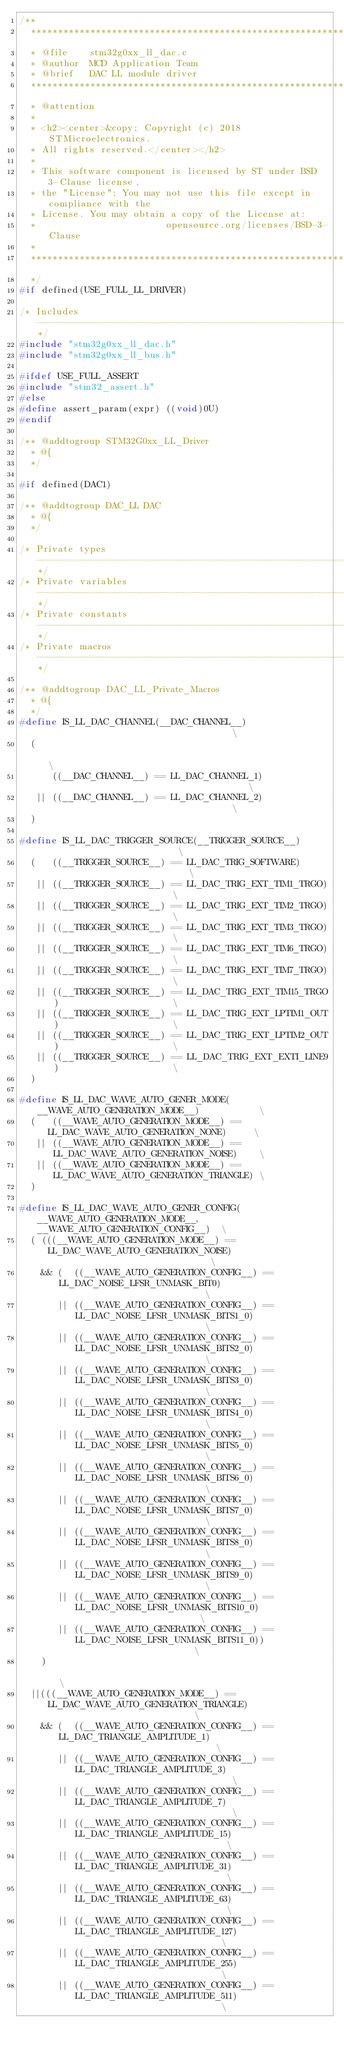<code> <loc_0><loc_0><loc_500><loc_500><_C_>/**
  ******************************************************************************
  * @file    stm32g0xx_ll_dac.c
  * @author  MCD Application Team
  * @brief   DAC LL module driver
  ******************************************************************************
  * @attention
  *
  * <h2><center>&copy; Copyright (c) 2018 STMicroelectronics.
  * All rights reserved.</center></h2>
  *
  * This software component is licensed by ST under BSD 3-Clause license,
  * the "License"; You may not use this file except in compliance with the
  * License. You may obtain a copy of the License at:
  *                        opensource.org/licenses/BSD-3-Clause
  *
  ******************************************************************************
  */
#if defined(USE_FULL_LL_DRIVER)

/* Includes ------------------------------------------------------------------*/
#include "stm32g0xx_ll_dac.h"
#include "stm32g0xx_ll_bus.h"

#ifdef USE_FULL_ASSERT
#include "stm32_assert.h"
#else
#define assert_param(expr) ((void)0U)
#endif

/** @addtogroup STM32G0xx_LL_Driver
  * @{
  */

#if defined(DAC1)

/** @addtogroup DAC_LL DAC
  * @{
  */

/* Private types -------------------------------------------------------------*/
/* Private variables ---------------------------------------------------------*/
/* Private constants ---------------------------------------------------------*/
/* Private macros ------------------------------------------------------------*/

/** @addtogroup DAC_LL_Private_Macros
  * @{
  */
#define IS_LL_DAC_CHANNEL(__DAC_CHANNEL__)                                     \
  (                                                                            \
      ((__DAC_CHANNEL__) == LL_DAC_CHANNEL_1)                                  \
   || ((__DAC_CHANNEL__) == LL_DAC_CHANNEL_2)                                  \
  )

#define IS_LL_DAC_TRIGGER_SOURCE(__TRIGGER_SOURCE__)                           \
  (   ((__TRIGGER_SOURCE__) == LL_DAC_TRIG_SOFTWARE)                           \
   || ((__TRIGGER_SOURCE__) == LL_DAC_TRIG_EXT_TIM1_TRGO)                      \
   || ((__TRIGGER_SOURCE__) == LL_DAC_TRIG_EXT_TIM2_TRGO)                      \
   || ((__TRIGGER_SOURCE__) == LL_DAC_TRIG_EXT_TIM3_TRGO)                      \
   || ((__TRIGGER_SOURCE__) == LL_DAC_TRIG_EXT_TIM6_TRGO)                      \
   || ((__TRIGGER_SOURCE__) == LL_DAC_TRIG_EXT_TIM7_TRGO)                      \
   || ((__TRIGGER_SOURCE__) == LL_DAC_TRIG_EXT_TIM15_TRGO)                     \
   || ((__TRIGGER_SOURCE__) == LL_DAC_TRIG_EXT_LPTIM1_OUT)                     \
   || ((__TRIGGER_SOURCE__) == LL_DAC_TRIG_EXT_LPTIM2_OUT)                     \
   || ((__TRIGGER_SOURCE__) == LL_DAC_TRIG_EXT_EXTI_LINE9)                     \
  )

#define IS_LL_DAC_WAVE_AUTO_GENER_MODE(__WAVE_AUTO_GENERATION_MODE__)           \
  (   ((__WAVE_AUTO_GENERATION_MODE__) == LL_DAC_WAVE_AUTO_GENERATION_NONE)     \
   || ((__WAVE_AUTO_GENERATION_MODE__) == LL_DAC_WAVE_AUTO_GENERATION_NOISE)    \
   || ((__WAVE_AUTO_GENERATION_MODE__) == LL_DAC_WAVE_AUTO_GENERATION_TRIANGLE) \
  )

#define IS_LL_DAC_WAVE_AUTO_GENER_CONFIG(__WAVE_AUTO_GENERATION_MODE__, __WAVE_AUTO_GENERATION_CONFIG__)  \
  ( (((__WAVE_AUTO_GENERATION_MODE__) == LL_DAC_WAVE_AUTO_GENERATION_NOISE)                               \
    && (  ((__WAVE_AUTO_GENERATION_CONFIG__) == LL_DAC_NOISE_LFSR_UNMASK_BIT0)                            \
       || ((__WAVE_AUTO_GENERATION_CONFIG__) == LL_DAC_NOISE_LFSR_UNMASK_BITS1_0)                         \
       || ((__WAVE_AUTO_GENERATION_CONFIG__) == LL_DAC_NOISE_LFSR_UNMASK_BITS2_0)                         \
       || ((__WAVE_AUTO_GENERATION_CONFIG__) == LL_DAC_NOISE_LFSR_UNMASK_BITS3_0)                         \
       || ((__WAVE_AUTO_GENERATION_CONFIG__) == LL_DAC_NOISE_LFSR_UNMASK_BITS4_0)                         \
       || ((__WAVE_AUTO_GENERATION_CONFIG__) == LL_DAC_NOISE_LFSR_UNMASK_BITS5_0)                         \
       || ((__WAVE_AUTO_GENERATION_CONFIG__) == LL_DAC_NOISE_LFSR_UNMASK_BITS6_0)                         \
       || ((__WAVE_AUTO_GENERATION_CONFIG__) == LL_DAC_NOISE_LFSR_UNMASK_BITS7_0)                         \
       || ((__WAVE_AUTO_GENERATION_CONFIG__) == LL_DAC_NOISE_LFSR_UNMASK_BITS8_0)                         \
       || ((__WAVE_AUTO_GENERATION_CONFIG__) == LL_DAC_NOISE_LFSR_UNMASK_BITS9_0)                         \
       || ((__WAVE_AUTO_GENERATION_CONFIG__) == LL_DAC_NOISE_LFSR_UNMASK_BITS10_0)                        \
       || ((__WAVE_AUTO_GENERATION_CONFIG__) == LL_DAC_NOISE_LFSR_UNMASK_BITS11_0))                       \
    )                                                                                                     \
  ||(((__WAVE_AUTO_GENERATION_MODE__) == LL_DAC_WAVE_AUTO_GENERATION_TRIANGLE)                            \
    && (  ((__WAVE_AUTO_GENERATION_CONFIG__) == LL_DAC_TRIANGLE_AMPLITUDE_1)                              \
       || ((__WAVE_AUTO_GENERATION_CONFIG__) == LL_DAC_TRIANGLE_AMPLITUDE_3)                              \
       || ((__WAVE_AUTO_GENERATION_CONFIG__) == LL_DAC_TRIANGLE_AMPLITUDE_7)                              \
       || ((__WAVE_AUTO_GENERATION_CONFIG__) == LL_DAC_TRIANGLE_AMPLITUDE_15)                             \
       || ((__WAVE_AUTO_GENERATION_CONFIG__) == LL_DAC_TRIANGLE_AMPLITUDE_31)                             \
       || ((__WAVE_AUTO_GENERATION_CONFIG__) == LL_DAC_TRIANGLE_AMPLITUDE_63)                             \
       || ((__WAVE_AUTO_GENERATION_CONFIG__) == LL_DAC_TRIANGLE_AMPLITUDE_127)                            \
       || ((__WAVE_AUTO_GENERATION_CONFIG__) == LL_DAC_TRIANGLE_AMPLITUDE_255)                            \
       || ((__WAVE_AUTO_GENERATION_CONFIG__) == LL_DAC_TRIANGLE_AMPLITUDE_511)                            \</code> 